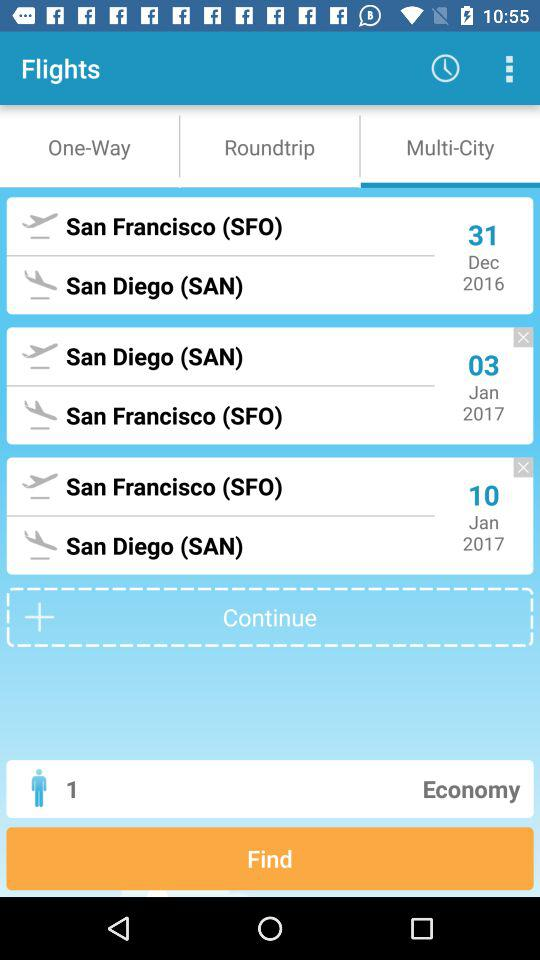What's the arrival destination on 03rd of January 2017? The arrival destination is San Francisco (SFO). 